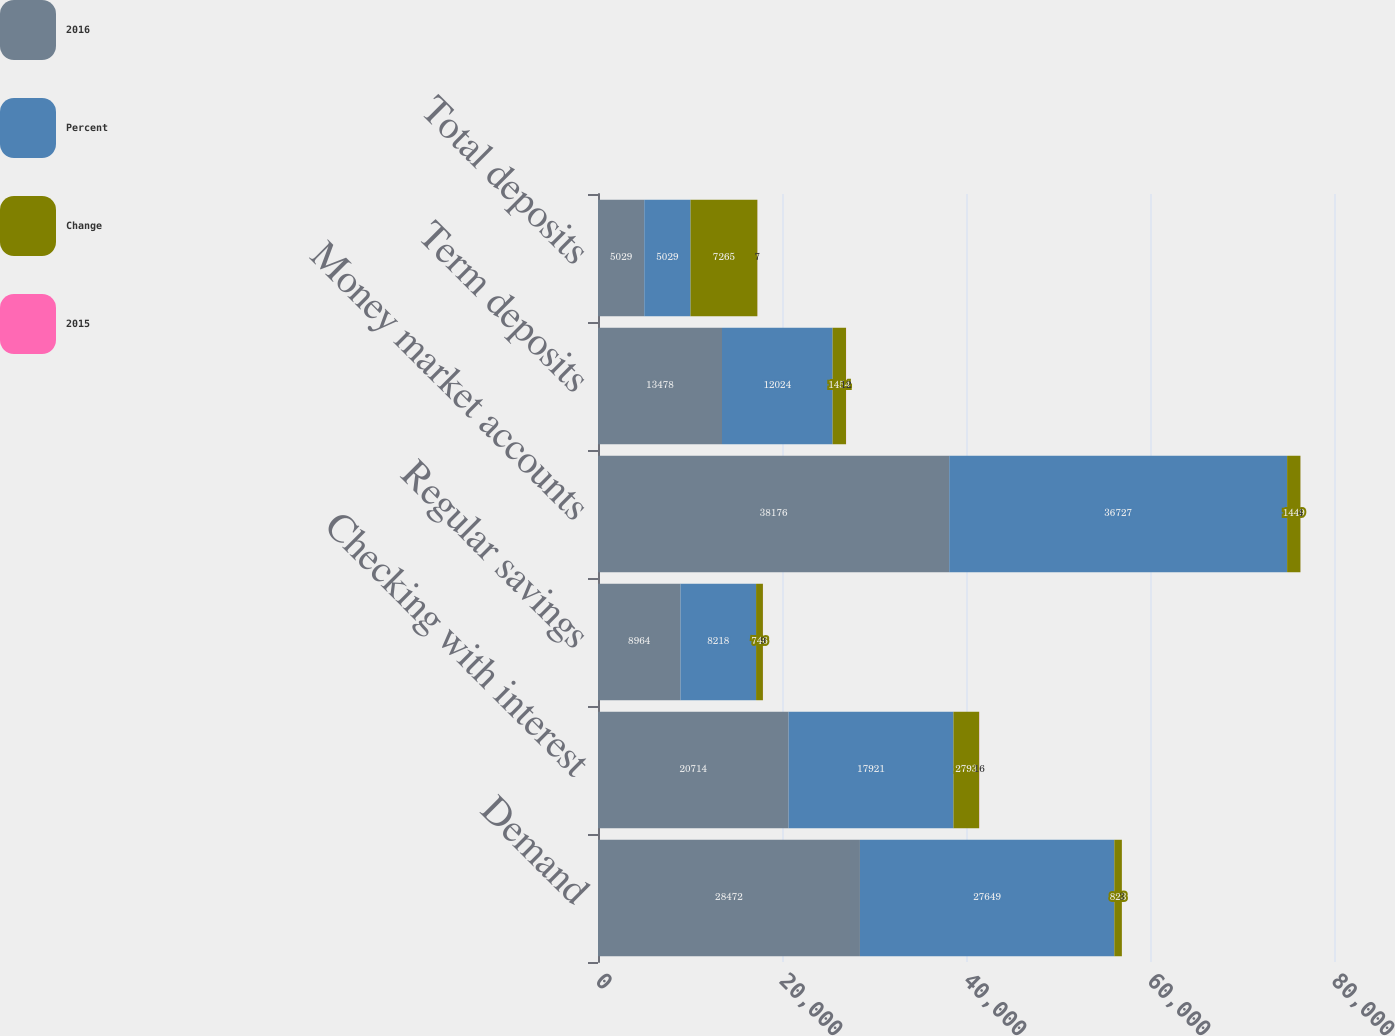<chart> <loc_0><loc_0><loc_500><loc_500><stacked_bar_chart><ecel><fcel>Demand<fcel>Checking with interest<fcel>Regular savings<fcel>Money market accounts<fcel>Term deposits<fcel>Total deposits<nl><fcel>2016<fcel>28472<fcel>20714<fcel>8964<fcel>38176<fcel>13478<fcel>5029<nl><fcel>Percent<fcel>27649<fcel>17921<fcel>8218<fcel>36727<fcel>12024<fcel>5029<nl><fcel>Change<fcel>823<fcel>2793<fcel>746<fcel>1449<fcel>1454<fcel>7265<nl><fcel>2015<fcel>3<fcel>16<fcel>9<fcel>4<fcel>12<fcel>7<nl></chart> 